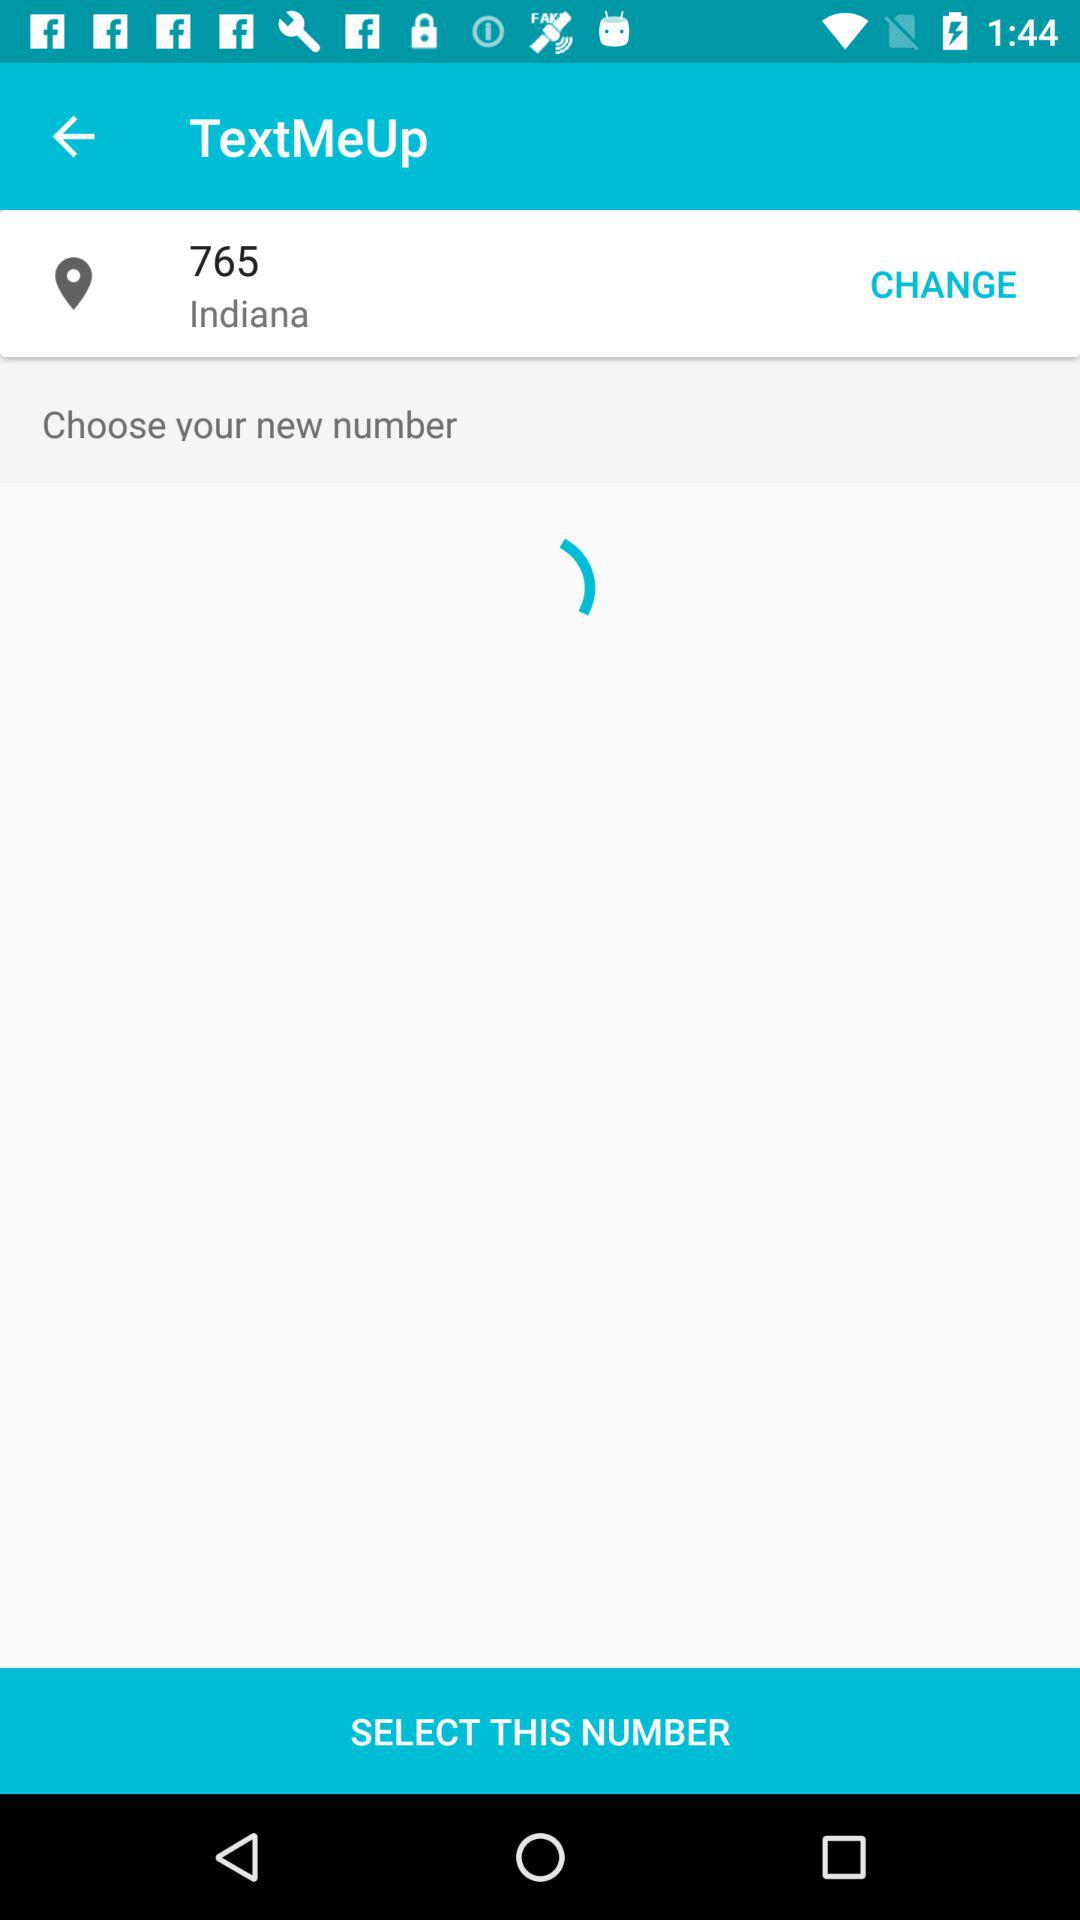What is the application name? The application name is "TextMeUp". 